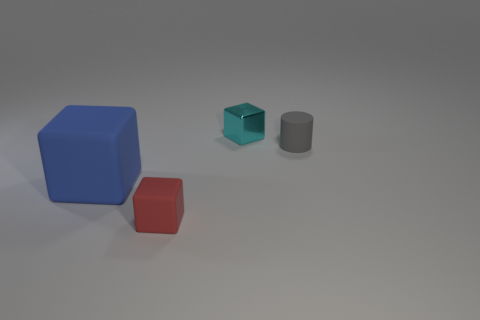What is the texture of the surface on which the objects are resting? The surface appears to be smooth with a matte finish, reflecting some light, indicative of a non-glossy material. 